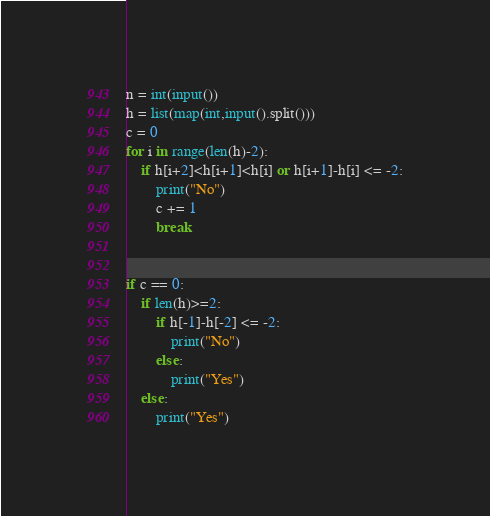<code> <loc_0><loc_0><loc_500><loc_500><_Python_>n = int(input())
h = list(map(int,input().split()))
c = 0
for i in range(len(h)-2):
    if h[i+2]<h[i+1]<h[i] or h[i+1]-h[i] <= -2:
        print("No")
        c += 1
        break
    
        
if c == 0:
    if len(h)>=2:
        if h[-1]-h[-2] <= -2:
            print("No")
        else:
            print("Yes")
    else:
        print("Yes")</code> 